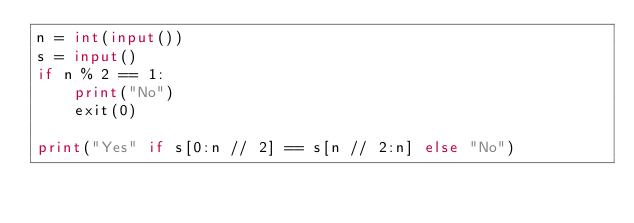Convert code to text. <code><loc_0><loc_0><loc_500><loc_500><_Python_>n = int(input())
s = input()
if n % 2 == 1:
    print("No")
    exit(0)

print("Yes" if s[0:n // 2] == s[n // 2:n] else "No")
</code> 